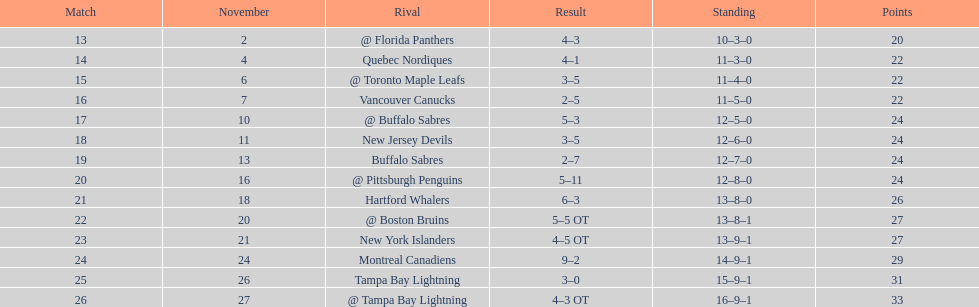The 1993-1994 flyers missed the playoffs again. how many consecutive seasons up until 93-94 did the flyers miss the playoffs? 5. 